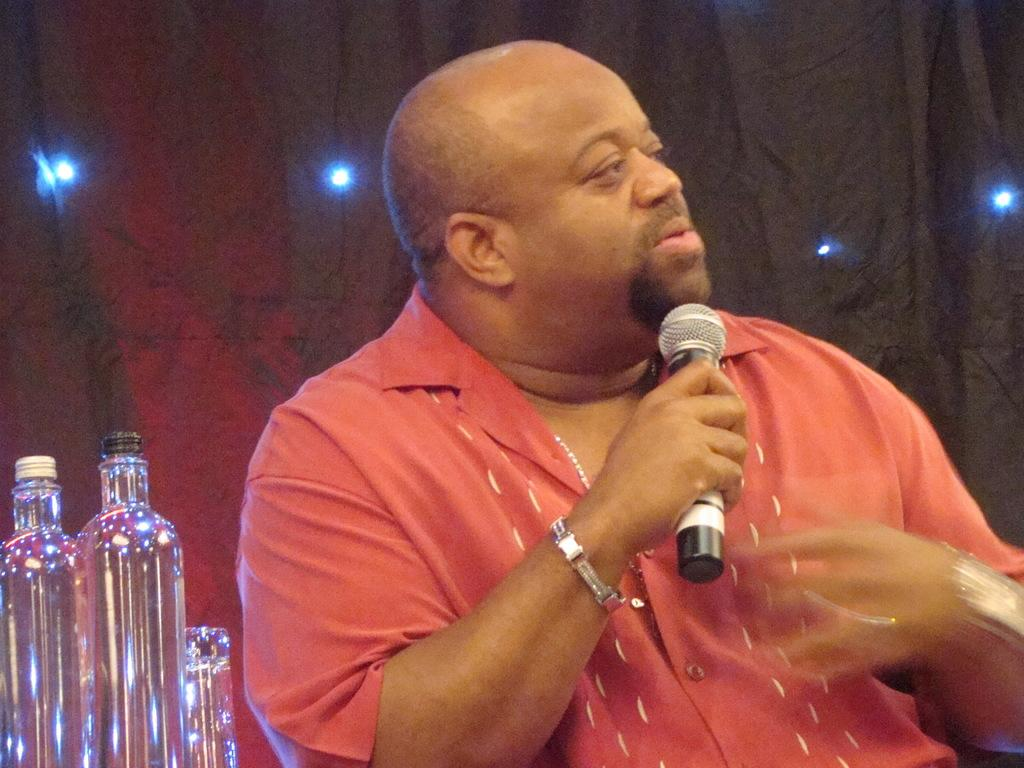What is the main subject of the image? There is a person in the image. What is the person holding in the image? The person is holding a microphone. What other objects are visible near the person? There are glass bottles beside the person. What type of stone can be seen rolling down the street in the image? There is no stone or street present in the image; it features a person holding a microphone and glass bottles nearby. 